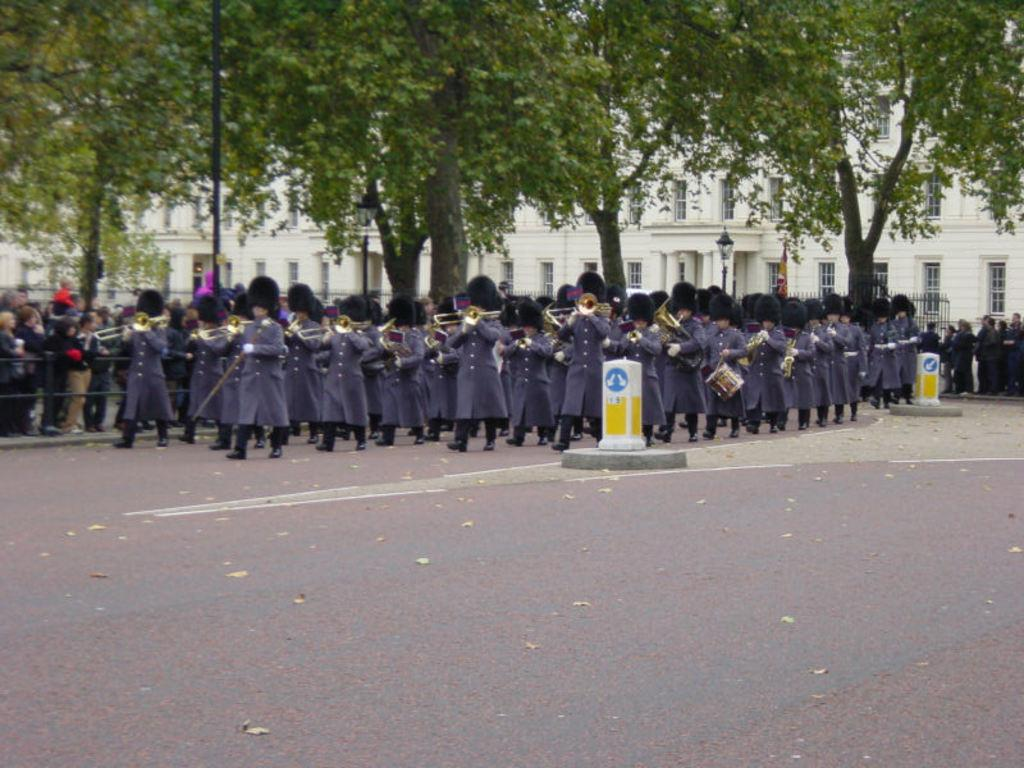What are the people in the image doing? People are playing musical instruments in the image. What can be seen in the background of the image? White buildings are visible in the background of the image. What type of structure is present in the image? There is a black fence in the image. Are there any other people in the image besides those playing musical instruments? Yes, there are other people standing in the image. What type of vegetation is present in the image? There are trees in the image. What other object can be seen in the image? There is a pole in the image. What type of scale can be seen in the image? There is no scale present in the image. Is this image taken in a park? The image does not provide enough information to determine if it was taken in a park or not. 